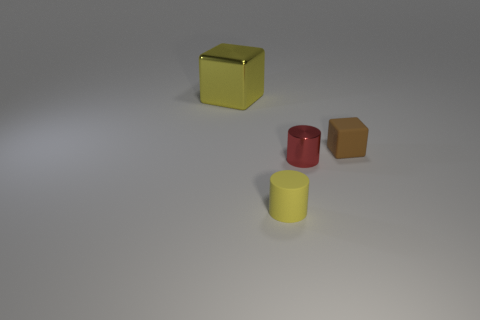What number of things are either big metal cubes or gray metal blocks?
Keep it short and to the point. 1. Are there more yellow metal cubes than cyan metal cylinders?
Give a very brief answer. Yes. There is a yellow thing on the left side of the rubber object that is in front of the brown rubber cube; what size is it?
Your answer should be compact. Large. There is a small thing that is the same shape as the big yellow thing; what color is it?
Give a very brief answer. Brown. The yellow metallic cube is what size?
Make the answer very short. Large. What number of blocks are big cyan metallic things or small red metallic objects?
Offer a terse response. 0. What size is the other rubber thing that is the same shape as the tiny red object?
Offer a very short reply. Small. How many yellow blocks are there?
Give a very brief answer. 1. Is the shape of the big thing the same as the metal object that is in front of the tiny cube?
Your response must be concise. No. How big is the metallic thing that is right of the big yellow cube?
Give a very brief answer. Small. 